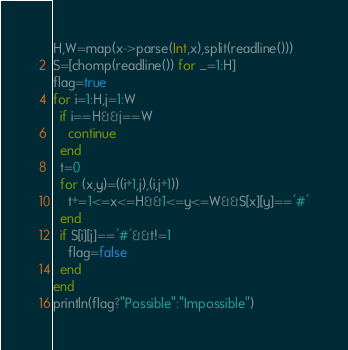<code> <loc_0><loc_0><loc_500><loc_500><_Julia_>H,W=map(x->parse(Int,x),split(readline()))
S=[chomp(readline()) for _=1:H]
flag=true
for i=1:H,j=1:W
  if i==H&&j==W
    continue
  end
  t=0
  for (x,y)=((i+1,j),(i,j+1))
    t+=1<=x<=H&&1<=y<=W&&S[x][y]=='#'
  end
  if S[i][j]=='#'&&t!=1
    flag=false
  end
end
println(flag?"Possible":"Impossible")</code> 